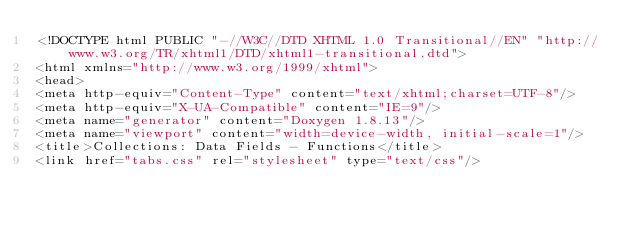<code> <loc_0><loc_0><loc_500><loc_500><_HTML_><!DOCTYPE html PUBLIC "-//W3C//DTD XHTML 1.0 Transitional//EN" "http://www.w3.org/TR/xhtml1/DTD/xhtml1-transitional.dtd">
<html xmlns="http://www.w3.org/1999/xhtml">
<head>
<meta http-equiv="Content-Type" content="text/xhtml;charset=UTF-8"/>
<meta http-equiv="X-UA-Compatible" content="IE=9"/>
<meta name="generator" content="Doxygen 1.8.13"/>
<meta name="viewport" content="width=device-width, initial-scale=1"/>
<title>Collections: Data Fields - Functions</title>
<link href="tabs.css" rel="stylesheet" type="text/css"/></code> 